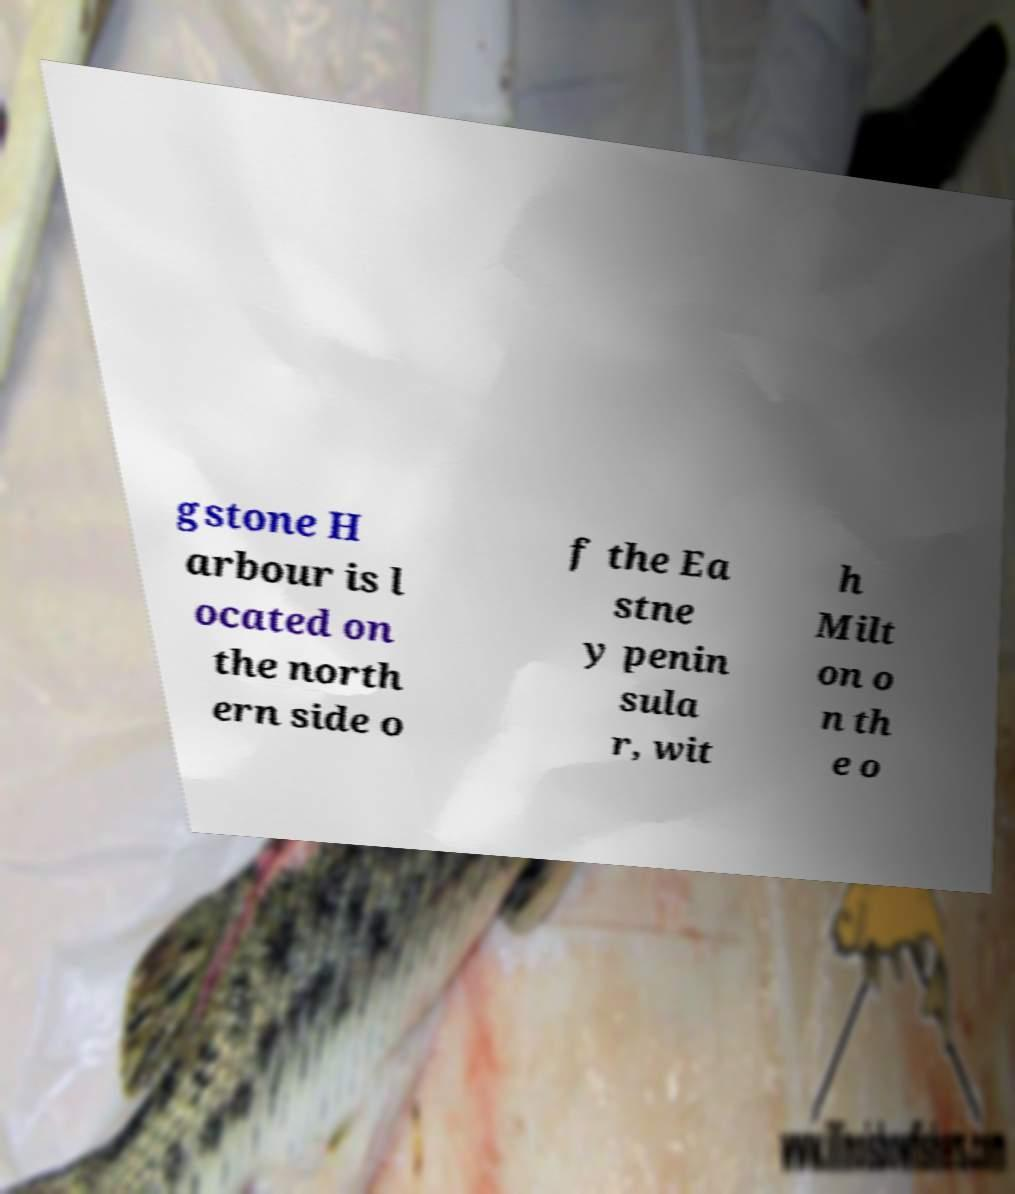Please read and relay the text visible in this image. What does it say? gstone H arbour is l ocated on the north ern side o f the Ea stne y penin sula r, wit h Milt on o n th e o 